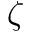<formula> <loc_0><loc_0><loc_500><loc_500>\zeta</formula> 